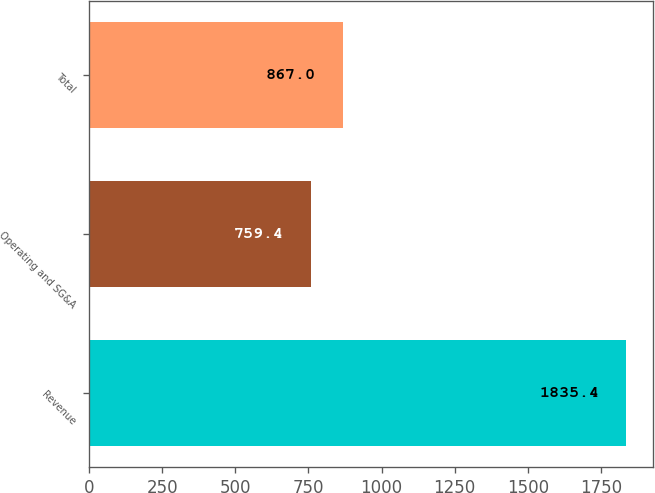Convert chart to OTSL. <chart><loc_0><loc_0><loc_500><loc_500><bar_chart><fcel>Revenue<fcel>Operating and SG&A<fcel>Total<nl><fcel>1835.4<fcel>759.4<fcel>867<nl></chart> 